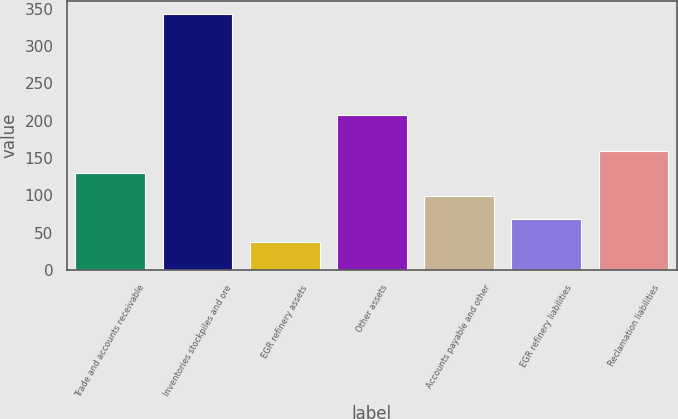Convert chart to OTSL. <chart><loc_0><loc_0><loc_500><loc_500><bar_chart><fcel>Trade and accounts receivable<fcel>Inventories stockpiles and ore<fcel>EGR refinery assets<fcel>Other assets<fcel>Accounts payable and other<fcel>EGR refinery liabilities<fcel>Reclamation liabilities<nl><fcel>129.5<fcel>343<fcel>38<fcel>208<fcel>99<fcel>68.5<fcel>160<nl></chart> 